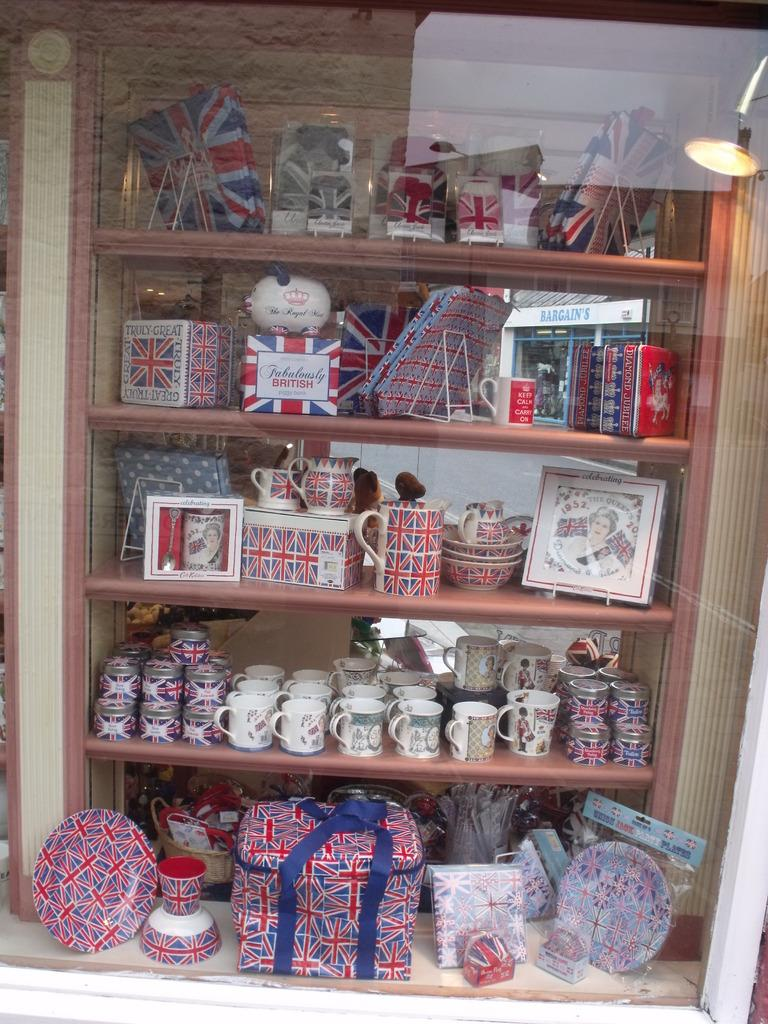What type of objects can be seen in the image? There are cups in the image. Are there any other objects present besides the cups? Yes, there are other objects in the image. How are the objects arranged in the image? The objects are kept in a rack. Can you describe the appearance of the rack? The rack can be seen through a glass in the middle of the image. Can you tell me how many dogs are chained to the rack in the image? There are no dogs or chains present in the image. 